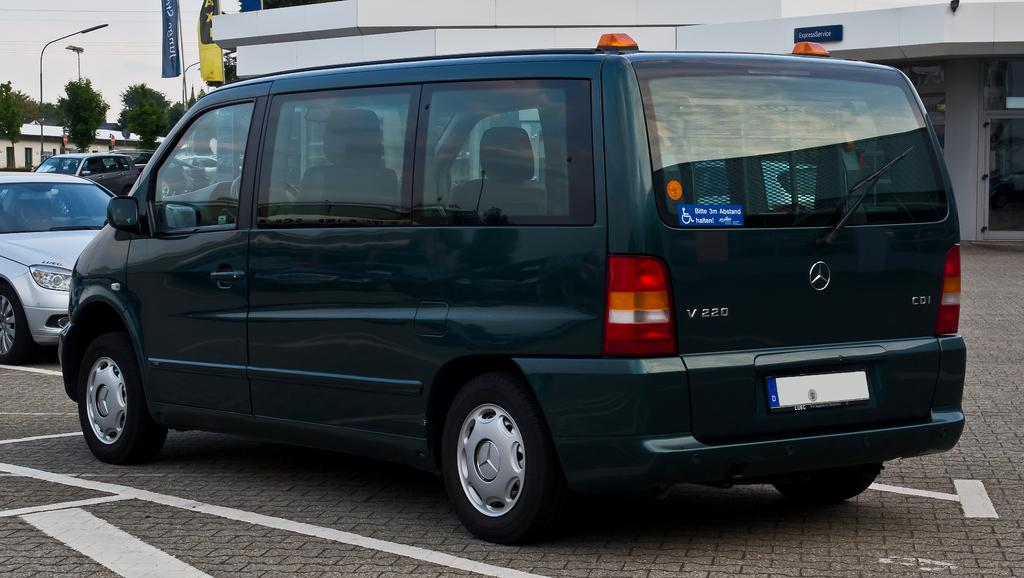What can be seen on the road in the image? There are vehicles on the road in the image. What is visible in the background of the image? There are buildings, trees, and poles in the background of the image. Are there any additional elements in the image? Yes, there are flags in the image. Can you tell me how many crows are sitting on the vehicles in the image? There are no crows present in the image; it features vehicles on the road, buildings, trees, poles, and flags. How does the person in the image touch the flag? There is no person present in the image; it only shows vehicles, buildings, trees, poles, and flags. 